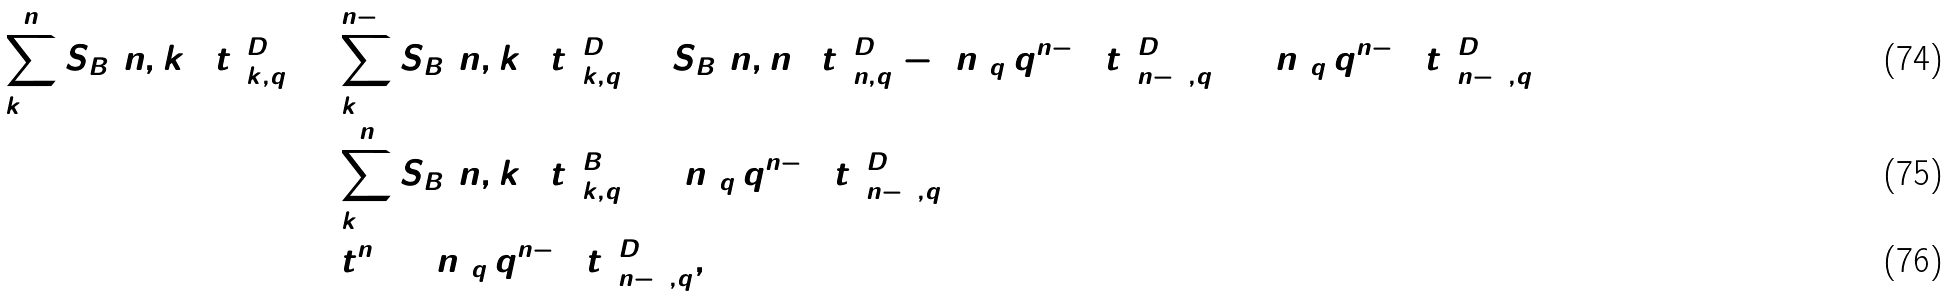<formula> <loc_0><loc_0><loc_500><loc_500>\sum _ { k = 0 } ^ { n } S _ { B } [ n , k ] ( t ) _ { k , q } ^ { D } & = \sum _ { k = 0 } ^ { n - 1 } S _ { B } [ n , k ] ( t ) _ { k , q } ^ { D } + S _ { B } [ n , n ] ( t ) _ { n , q } ^ { D } - [ n ] _ { q } \, q ^ { n - 1 } ( t ) _ { n - 1 , q } ^ { D } + [ n ] _ { q } \, q ^ { n - 1 } ( t ) _ { n - 1 , q } ^ { D } \\ & = \sum _ { k = 0 } ^ { n } S _ { B } [ n , k ] ( t ) _ { k , q } ^ { B } + [ n ] _ { q } \, q ^ { n - 1 } ( t ) _ { n - 1 , q } ^ { D } \\ & = t ^ { n } + [ n ] _ { q } \, q ^ { n - 1 } ( t ) _ { n - 1 , q } ^ { D } ,</formula> 